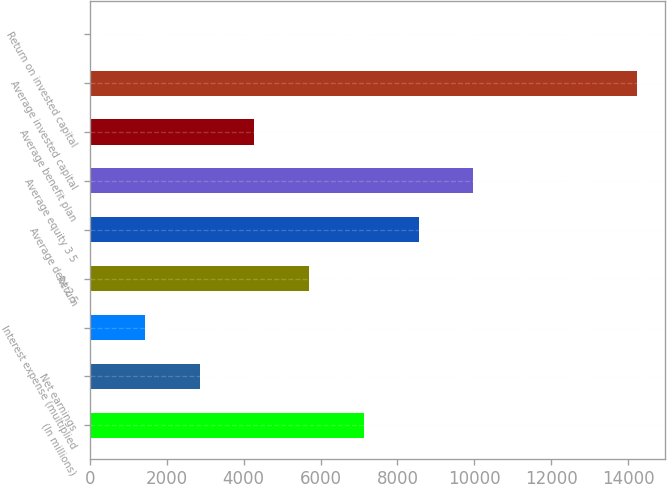Convert chart to OTSL. <chart><loc_0><loc_0><loc_500><loc_500><bar_chart><fcel>(In millions)<fcel>Net earnings<fcel>Interest expense (multiplied<fcel>Return<fcel>Average debt 2 5<fcel>Average equity 3 5<fcel>Average benefit plan<fcel>Average invested capital<fcel>Return on invested capital<nl><fcel>7126.9<fcel>2857.24<fcel>1434.02<fcel>5703.68<fcel>8550.12<fcel>9973.34<fcel>4280.46<fcel>14243<fcel>10.8<nl></chart> 